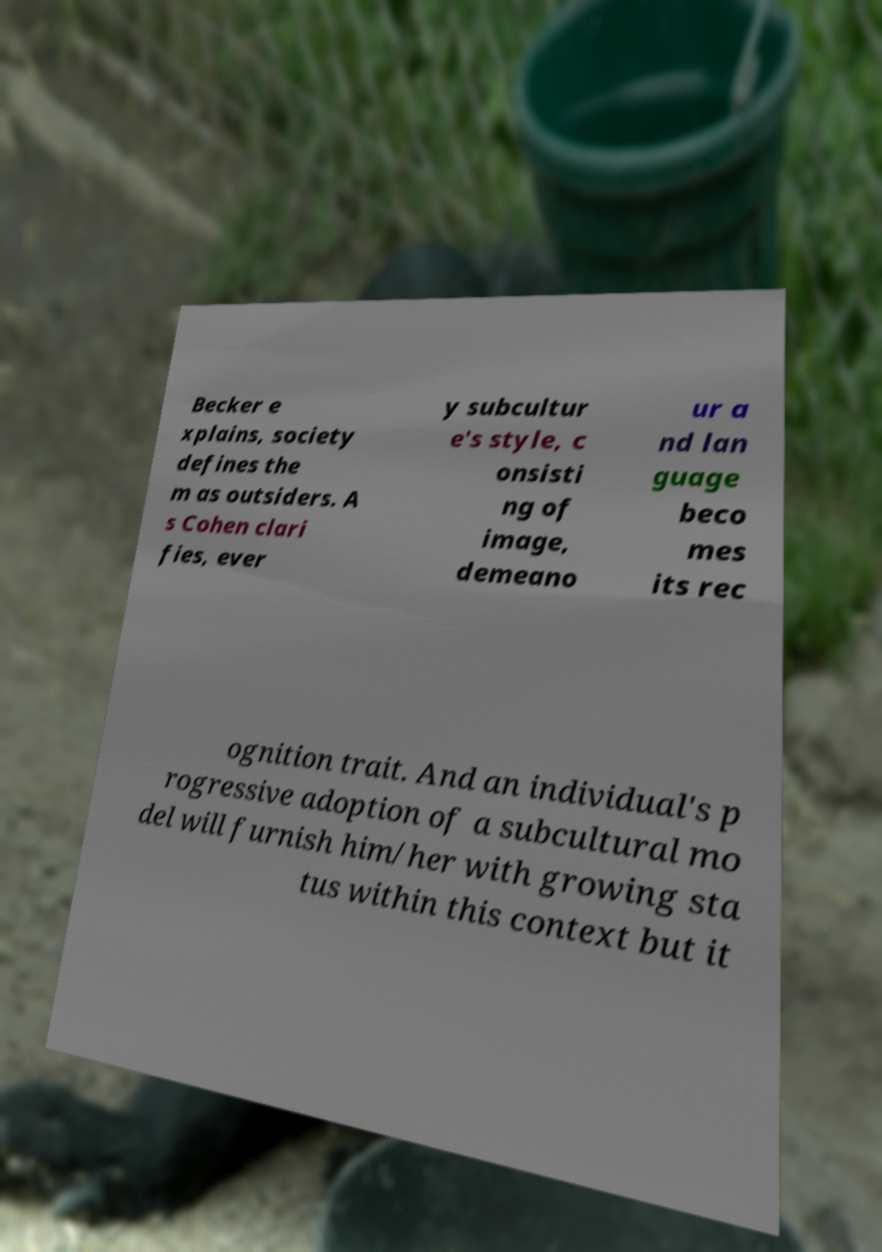For documentation purposes, I need the text within this image transcribed. Could you provide that? Becker e xplains, society defines the m as outsiders. A s Cohen clari fies, ever y subcultur e's style, c onsisti ng of image, demeano ur a nd lan guage beco mes its rec ognition trait. And an individual's p rogressive adoption of a subcultural mo del will furnish him/her with growing sta tus within this context but it 